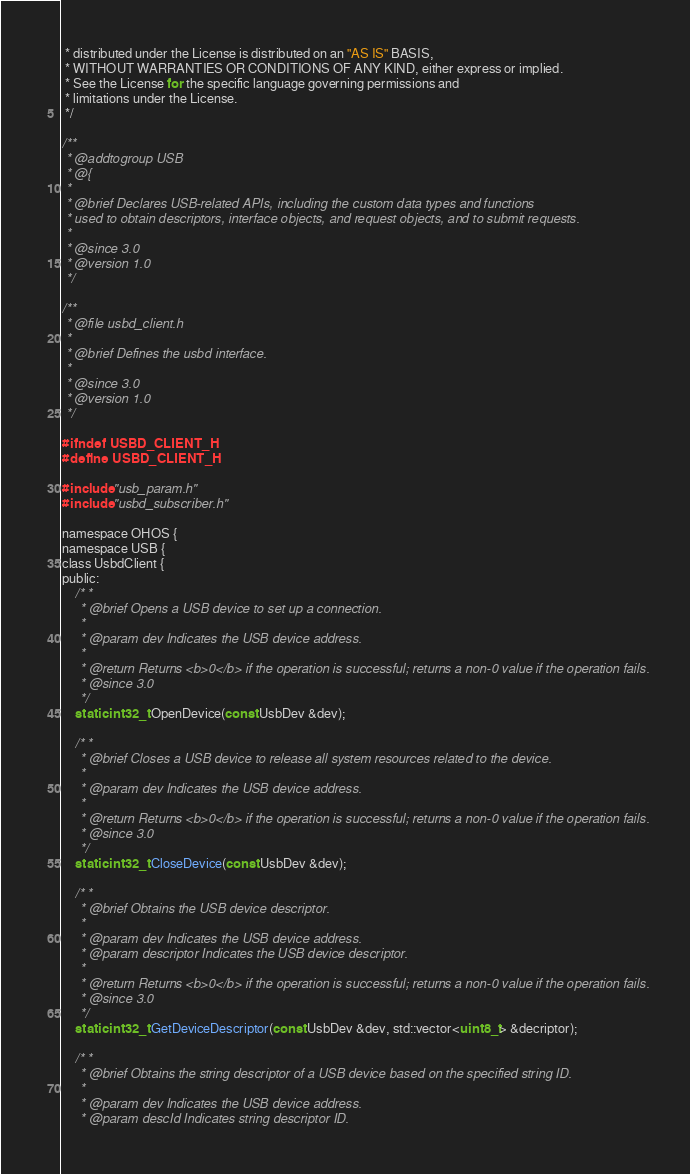Convert code to text. <code><loc_0><loc_0><loc_500><loc_500><_C_> * distributed under the License is distributed on an "AS IS" BASIS,
 * WITHOUT WARRANTIES OR CONDITIONS OF ANY KIND, either express or implied.
 * See the License for the specific language governing permissions and
 * limitations under the License.
 */

/**
 * @addtogroup USB
 * @{
 *
 * @brief Declares USB-related APIs, including the custom data types and functions
 * used to obtain descriptors, interface objects, and request objects, and to submit requests.
 *
 * @since 3.0
 * @version 1.0
 */

/**
 * @file usbd_client.h
 *
 * @brief Defines the usbd interface.
 *
 * @since 3.0
 * @version 1.0
 */

#ifndef USBD_CLIENT_H
#define USBD_CLIENT_H

#include "usb_param.h"
#include "usbd_subscriber.h"

namespace OHOS {
namespace USB {
class UsbdClient {
public:
    /* *
     * @brief Opens a USB device to set up a connection.
     *
     * @param dev Indicates the USB device address.
     *
     * @return Returns <b>0</b> if the operation is successful; returns a non-0 value if the operation fails.
     * @since 3.0
     */
    static int32_t OpenDevice(const UsbDev &dev);

    /* *
     * @brief Closes a USB device to release all system resources related to the device.
     *
     * @param dev Indicates the USB device address.
     *
     * @return Returns <b>0</b> if the operation is successful; returns a non-0 value if the operation fails.
     * @since 3.0
     */
    static int32_t CloseDevice(const UsbDev &dev);

    /* *
     * @brief Obtains the USB device descriptor.
     *
     * @param dev Indicates the USB device address.
     * @param descriptor Indicates the USB device descriptor.
     *
     * @return Returns <b>0</b> if the operation is successful; returns a non-0 value if the operation fails.
     * @since 3.0
     */
    static int32_t GetDeviceDescriptor(const UsbDev &dev, std::vector<uint8_t> &decriptor);

    /* *
     * @brief Obtains the string descriptor of a USB device based on the specified string ID.
     *
     * @param dev Indicates the USB device address.
     * @param descId Indicates string descriptor ID.</code> 